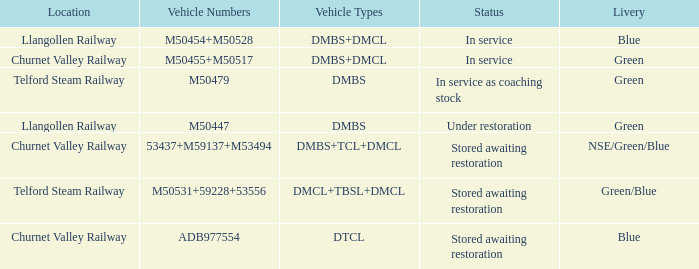What status is the vehicle numbers of adb977554? Stored awaiting restoration. 